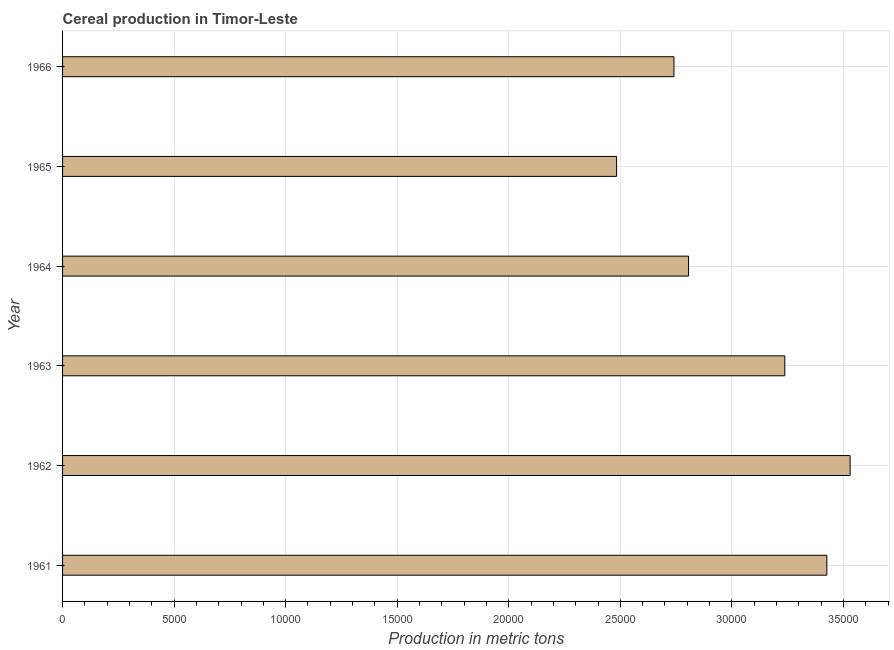What is the title of the graph?
Your answer should be very brief. Cereal production in Timor-Leste. What is the label or title of the X-axis?
Offer a terse response. Production in metric tons. What is the cereal production in 1961?
Your answer should be very brief. 3.43e+04. Across all years, what is the maximum cereal production?
Keep it short and to the point. 3.53e+04. Across all years, what is the minimum cereal production?
Keep it short and to the point. 2.48e+04. In which year was the cereal production minimum?
Offer a very short reply. 1965. What is the sum of the cereal production?
Give a very brief answer. 1.82e+05. What is the difference between the cereal production in 1962 and 1963?
Keep it short and to the point. 2928. What is the average cereal production per year?
Your answer should be compact. 3.04e+04. What is the median cereal production?
Your answer should be very brief. 3.02e+04. What is the ratio of the cereal production in 1962 to that in 1963?
Offer a very short reply. 1.09. What is the difference between the highest and the second highest cereal production?
Give a very brief answer. 1043. What is the difference between the highest and the lowest cereal production?
Keep it short and to the point. 1.05e+04. Are all the bars in the graph horizontal?
Offer a terse response. Yes. Are the values on the major ticks of X-axis written in scientific E-notation?
Keep it short and to the point. No. What is the Production in metric tons of 1961?
Your answer should be compact. 3.43e+04. What is the Production in metric tons of 1962?
Your answer should be compact. 3.53e+04. What is the Production in metric tons in 1963?
Provide a short and direct response. 3.24e+04. What is the Production in metric tons of 1964?
Offer a very short reply. 2.81e+04. What is the Production in metric tons in 1965?
Provide a short and direct response. 2.48e+04. What is the Production in metric tons of 1966?
Provide a short and direct response. 2.74e+04. What is the difference between the Production in metric tons in 1961 and 1962?
Offer a terse response. -1043. What is the difference between the Production in metric tons in 1961 and 1963?
Ensure brevity in your answer.  1885. What is the difference between the Production in metric tons in 1961 and 1964?
Your response must be concise. 6199. What is the difference between the Production in metric tons in 1961 and 1965?
Your answer should be very brief. 9424. What is the difference between the Production in metric tons in 1961 and 1966?
Your answer should be very brief. 6853. What is the difference between the Production in metric tons in 1962 and 1963?
Keep it short and to the point. 2928. What is the difference between the Production in metric tons in 1962 and 1964?
Your answer should be compact. 7242. What is the difference between the Production in metric tons in 1962 and 1965?
Give a very brief answer. 1.05e+04. What is the difference between the Production in metric tons in 1962 and 1966?
Offer a terse response. 7896. What is the difference between the Production in metric tons in 1963 and 1964?
Keep it short and to the point. 4314. What is the difference between the Production in metric tons in 1963 and 1965?
Offer a very short reply. 7539. What is the difference between the Production in metric tons in 1963 and 1966?
Your response must be concise. 4968. What is the difference between the Production in metric tons in 1964 and 1965?
Offer a terse response. 3225. What is the difference between the Production in metric tons in 1964 and 1966?
Keep it short and to the point. 654. What is the difference between the Production in metric tons in 1965 and 1966?
Your answer should be very brief. -2571. What is the ratio of the Production in metric tons in 1961 to that in 1963?
Provide a succinct answer. 1.06. What is the ratio of the Production in metric tons in 1961 to that in 1964?
Offer a very short reply. 1.22. What is the ratio of the Production in metric tons in 1961 to that in 1965?
Make the answer very short. 1.38. What is the ratio of the Production in metric tons in 1962 to that in 1963?
Provide a succinct answer. 1.09. What is the ratio of the Production in metric tons in 1962 to that in 1964?
Provide a succinct answer. 1.26. What is the ratio of the Production in metric tons in 1962 to that in 1965?
Your response must be concise. 1.42. What is the ratio of the Production in metric tons in 1962 to that in 1966?
Provide a succinct answer. 1.29. What is the ratio of the Production in metric tons in 1963 to that in 1964?
Give a very brief answer. 1.15. What is the ratio of the Production in metric tons in 1963 to that in 1965?
Ensure brevity in your answer.  1.3. What is the ratio of the Production in metric tons in 1963 to that in 1966?
Make the answer very short. 1.18. What is the ratio of the Production in metric tons in 1964 to that in 1965?
Ensure brevity in your answer.  1.13. What is the ratio of the Production in metric tons in 1964 to that in 1966?
Offer a very short reply. 1.02. What is the ratio of the Production in metric tons in 1965 to that in 1966?
Give a very brief answer. 0.91. 